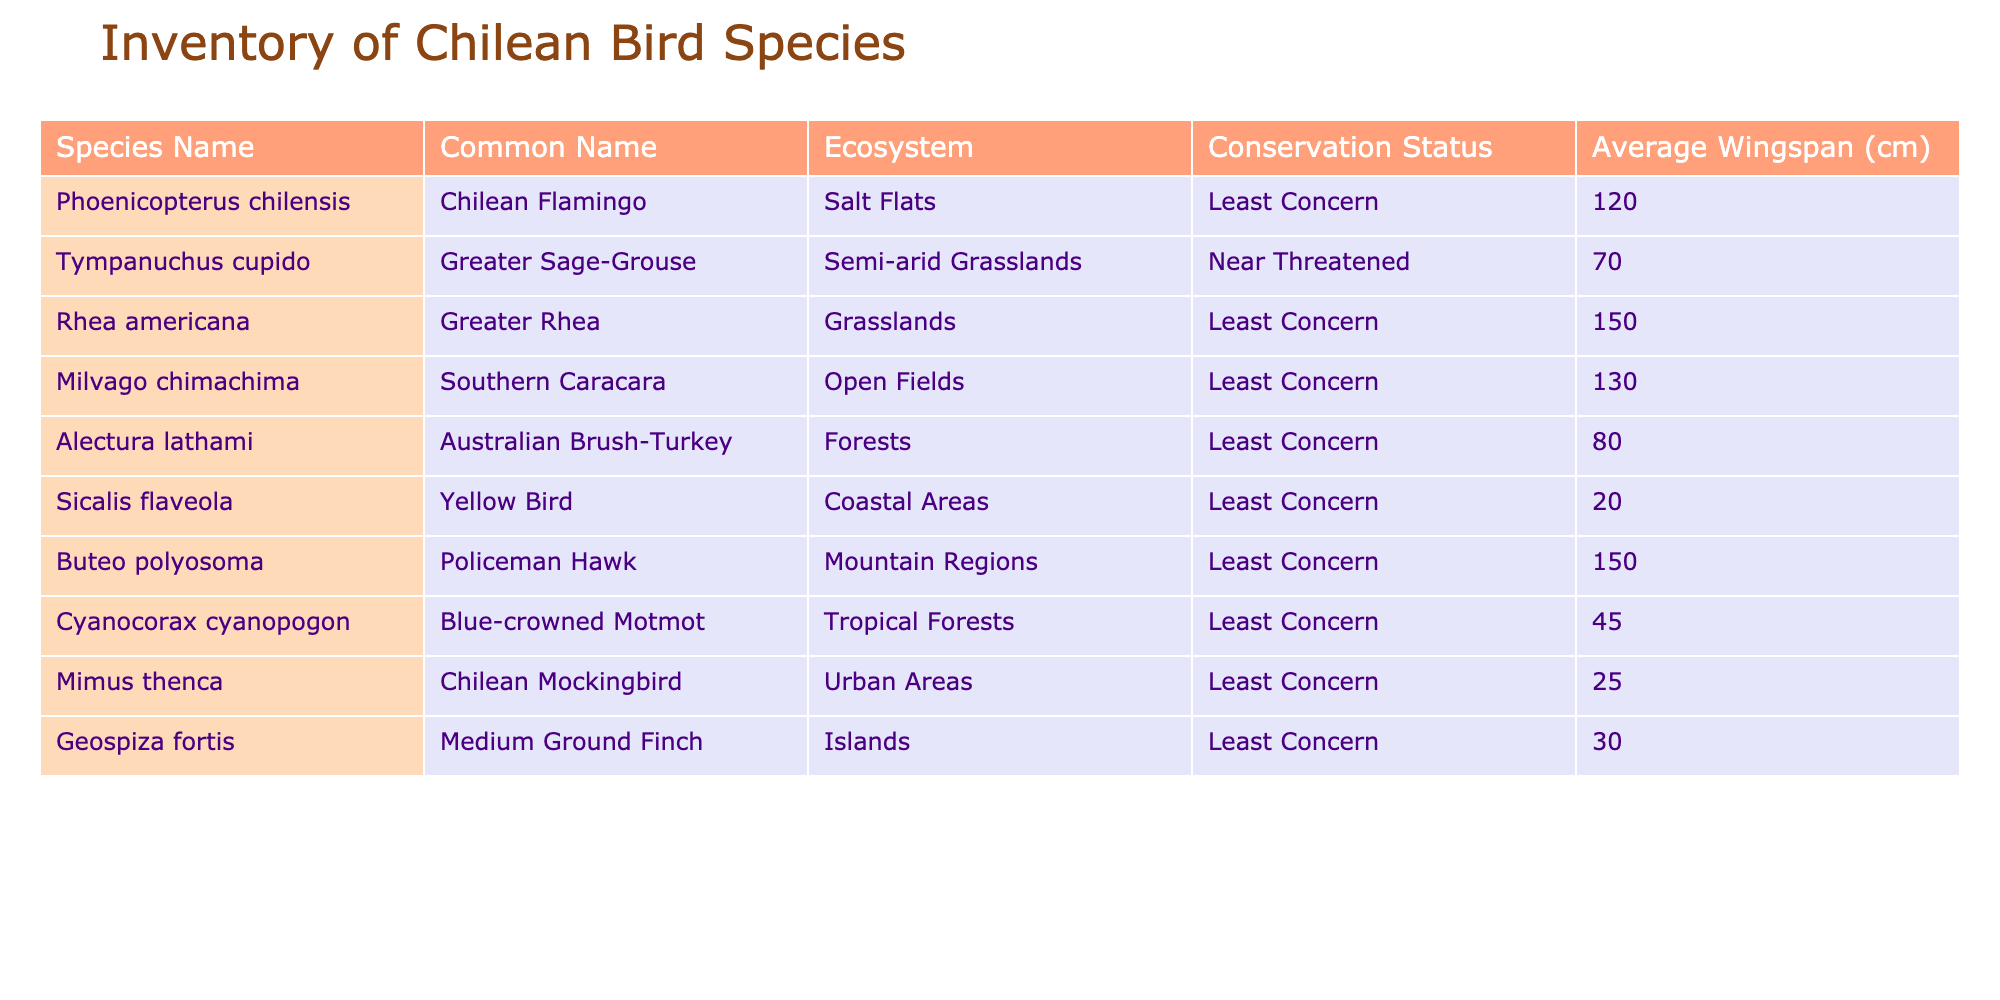What is the conservation status of the Chilean Flamingo? By looking at the row for the Chilean Flamingo (Phoenicopterus chilensis), we can see that its conservation status is listed as "Least Concern."
Answer: Least Concern How many species are observed in Coastal Areas? By checking the "Ecosystem" column for "Coastal Areas," we find that there is one species listed, which is the Yellow Bird (Sicalis flaveola).
Answer: 1 What is the average wingspan of birds observed in Urban Areas? The only species in Urban Areas is the Chilean Mockingbird (Mimus thenca), which has a wingspan of 25 cm. Therefore, the average wingspan is also 25 cm for that category.
Answer: 25 cm Does the Greater Rhea have a larger wingspan than the Southern Caracara? The wingspan of the Greater Rhea (Rhea americana) is 150 cm, while the wingspan of the Southern Caracara (Milvago chimachima) is 130 cm. Since 150 cm > 130 cm, the statement is true.
Answer: Yes What is the total wingspan of all observed bird species? To find the total wingspan, we need to sum all the values in the "Average Wingspan (cm)" column: 120 + 70 + 150 + 130 + 80 + 20 + 150 + 45 + 25 + 30 = 900 cm.
Answer: 900 cm Which bird has the smallest wingspan and what is it? We look at the "Average Wingspan (cm)" column and notice that the smallest value is 20 cm, which corresponds to the Yellow Bird (Sicalis flaveola).
Answer: Yellow Bird, 20 cm Are there any bird species with a wingspan greater than 140 cm? By scanning the "Average Wingspan (cm)" column, we see that both the Greater Rhea (150 cm) and the Policeman Hawk (150 cm) have wingspans greater than 140 cm. Therefore, the answer is yes.
Answer: Yes How many species are categorized as "Least Concern"? We count the entries in the "Conservation Status" column labeled as "Least Concern." There are a total of 8 species with this status.
Answer: 8 